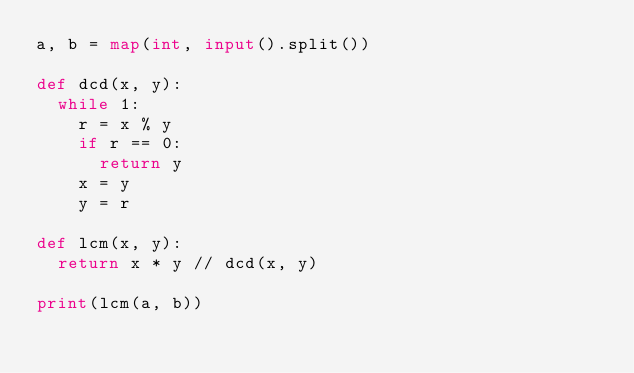Convert code to text. <code><loc_0><loc_0><loc_500><loc_500><_Python_>a, b = map(int, input().split())

def dcd(x, y):
  while 1:
    r = x % y
    if r == 0:
      return y
    x = y
    y = r

def lcm(x, y):
  return x * y // dcd(x, y)

print(lcm(a, b))</code> 